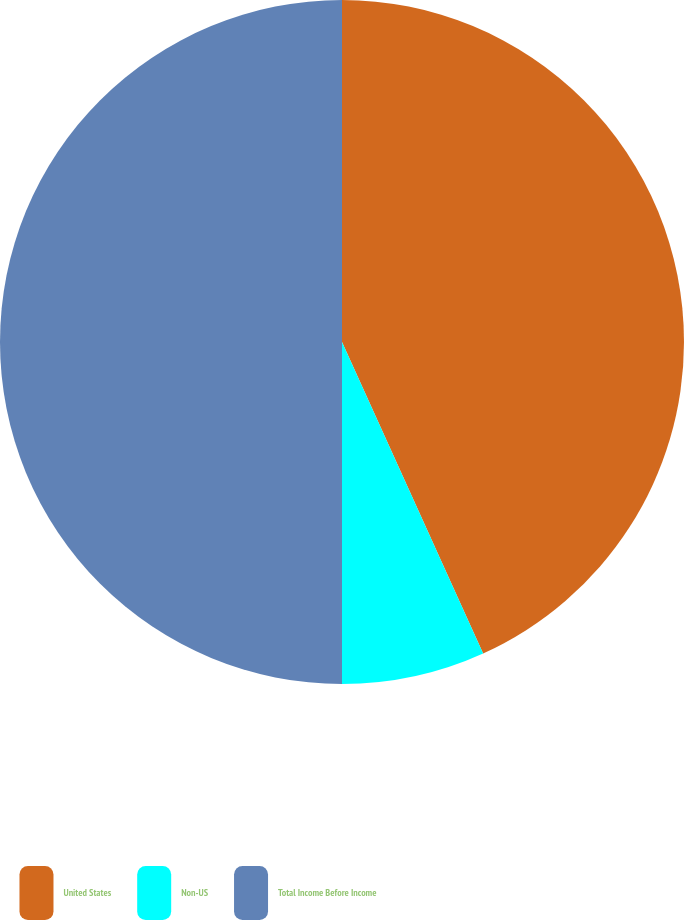Convert chart to OTSL. <chart><loc_0><loc_0><loc_500><loc_500><pie_chart><fcel>United States<fcel>Non-US<fcel>Total Income Before Income<nl><fcel>43.23%<fcel>6.77%<fcel>50.0%<nl></chart> 